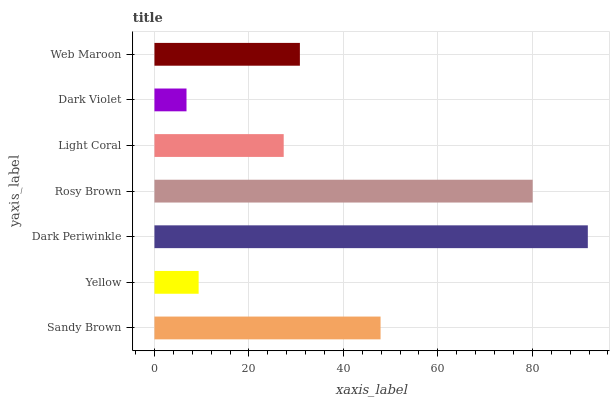Is Dark Violet the minimum?
Answer yes or no. Yes. Is Dark Periwinkle the maximum?
Answer yes or no. Yes. Is Yellow the minimum?
Answer yes or no. No. Is Yellow the maximum?
Answer yes or no. No. Is Sandy Brown greater than Yellow?
Answer yes or no. Yes. Is Yellow less than Sandy Brown?
Answer yes or no. Yes. Is Yellow greater than Sandy Brown?
Answer yes or no. No. Is Sandy Brown less than Yellow?
Answer yes or no. No. Is Web Maroon the high median?
Answer yes or no. Yes. Is Web Maroon the low median?
Answer yes or no. Yes. Is Rosy Brown the high median?
Answer yes or no. No. Is Dark Violet the low median?
Answer yes or no. No. 